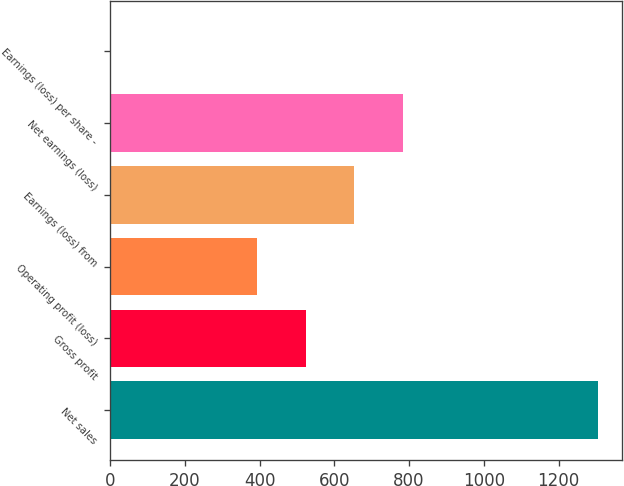Convert chart to OTSL. <chart><loc_0><loc_0><loc_500><loc_500><bar_chart><fcel>Net sales<fcel>Gross profit<fcel>Operating profit (loss)<fcel>Earnings (loss) from<fcel>Net earnings (loss)<fcel>Earnings (loss) per share -<nl><fcel>1304<fcel>523.13<fcel>392.98<fcel>653.28<fcel>783.43<fcel>2.53<nl></chart> 